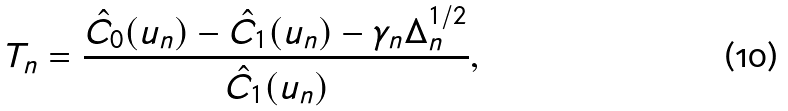<formula> <loc_0><loc_0><loc_500><loc_500>T _ { n } = \frac { \hat { C } _ { 0 } ( u _ { n } ) - \hat { C } _ { 1 } ( u _ { n } ) - \gamma _ { n } \Delta _ { n } ^ { 1 / 2 } } { \hat { C } _ { 1 } ( u _ { n } ) } ,</formula> 